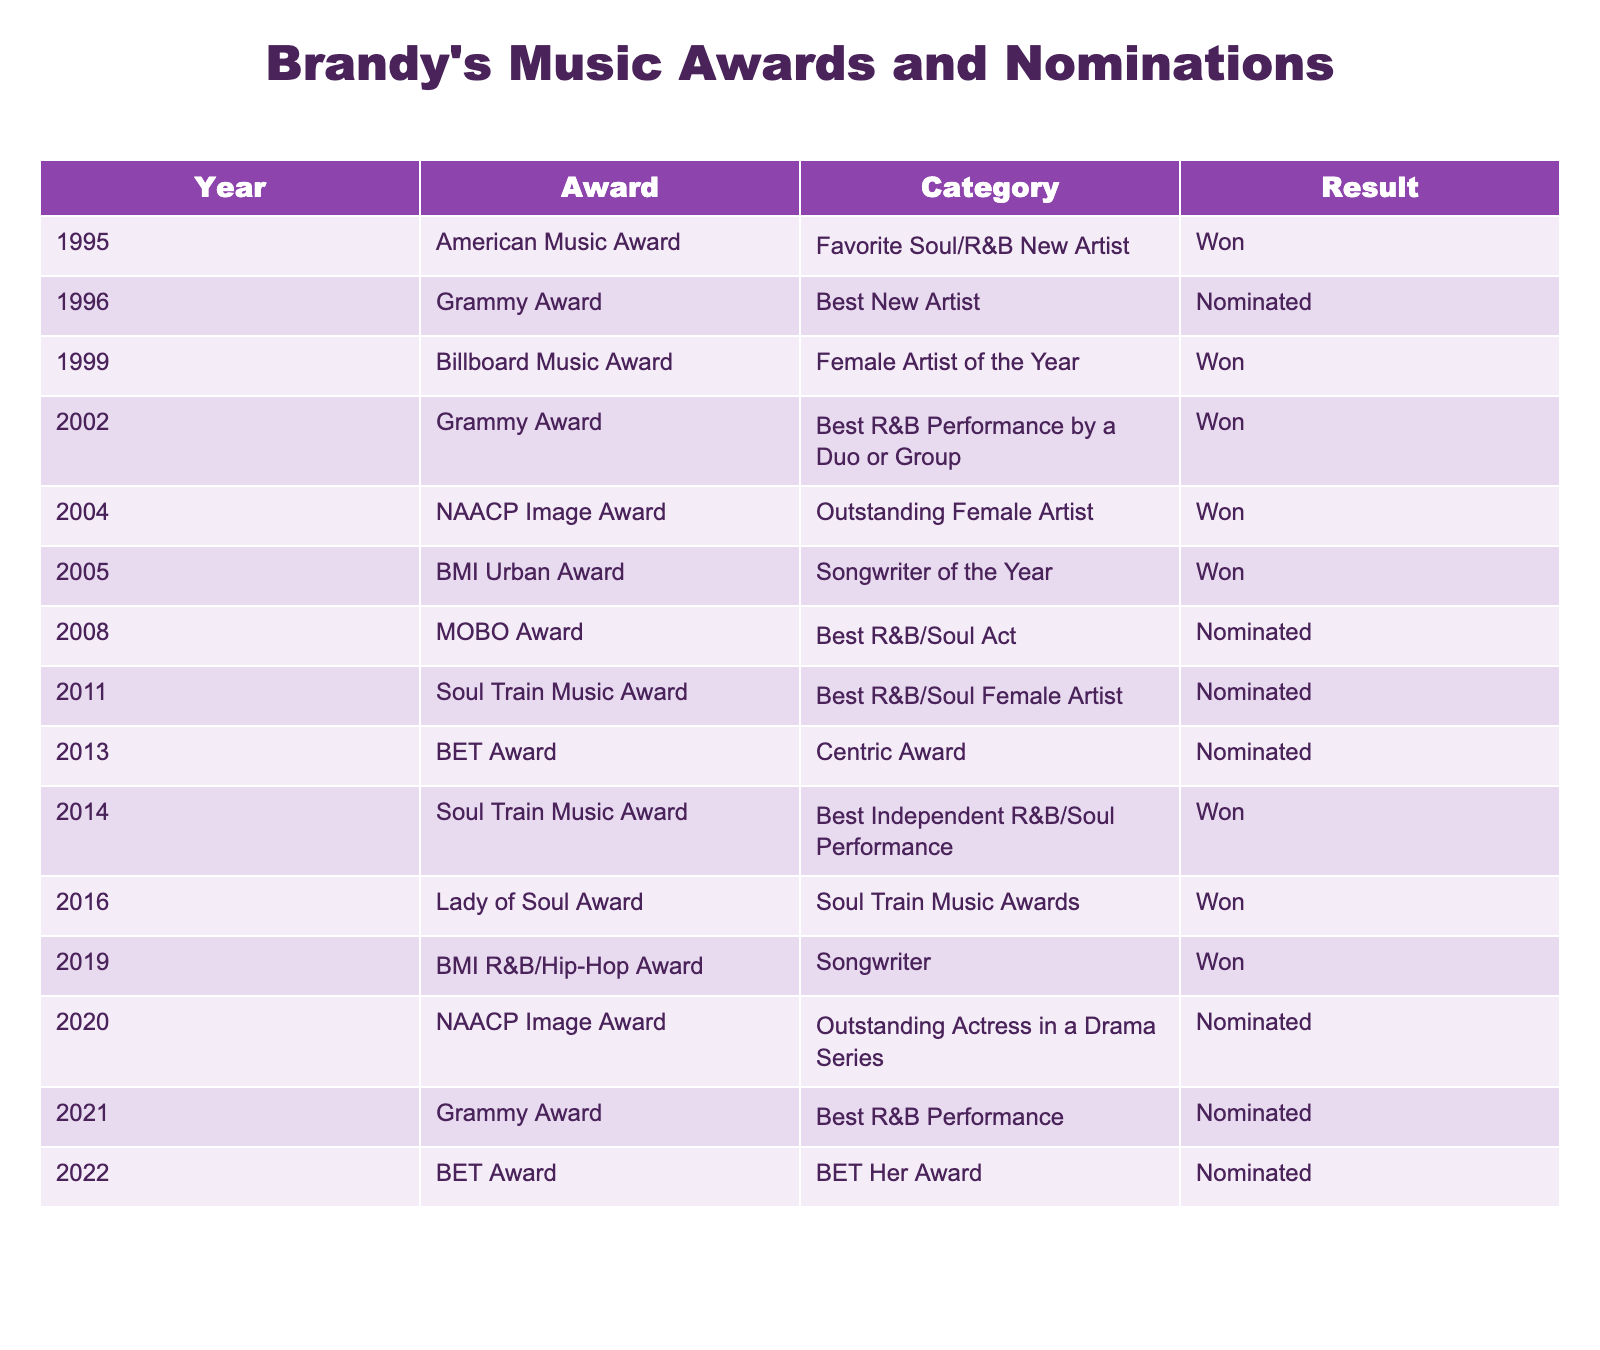What award did Brandy win in 1999? The table indicates that in 1999, Brandy won the Billboard Music Award for Female Artist of the Year.
Answer: Billboard Music Award How many awards did Brandy win in total according to the table? By counting the results labeled "Won" in the Result column, Brandy won a total of 6 awards from the table.
Answer: 6 Did Brandy receive a Grammy nomination in 2021? The table shows that in 2021, Brandy was nominated for a Grammy Award in the Best R&B Performance category, confirming that she received a nomination that year.
Answer: Yes Which year did Brandy win the NAACP Image Award? The table lists one NAACP Image Award win in 2004 for Outstanding Female Artist, indicating that this was the year of her win.
Answer: 2004 How many years did Brandy receive nominations without winning? From the table, we see 6 nominations listed without a win: 1996, 2008, 2011, 2013, 2020, and 2021; thus, she had 6 nomination years without wins.
Answer: 6 What is the ratio of won awards to nominated awards for Brandy? Brandy won 6 awards and received 7 nominations (6 + 7 = 13 total), so the ratio of won awards to nominations is 6:7.
Answer: 6:7 In what category did Brandy receive her first award? The first award listed in the table is the American Music Award for Favorite Soul/R&B New Artist in 1995, marking her first win.
Answer: Favorite Soul/R&B New Artist What is the most recent award Brandy was nominated for? The table indicates that the most recent nomination was for the BET Her Award in 2022, showing the latest award she contended for.
Answer: BET Her Award How many years did Brandy achieve wins consecutively starting from 1999 until 2005? Between 1999 and 2005, Brandy won awards in 1999, 2002, 2004, and 2005, achieving 4 wins over 7 years, accounting for 4 winning years consecutively between 1999 and 2005.
Answer: 4 What type of awards did Brandy primarily win throughout her career based on this table? Analyzing the table, it can be seen that the majority of her wins are from music-related awards such as Billboard, Grammy, and Soul Train Awards, indicating a focus on music categories.
Answer: Music-related awards 